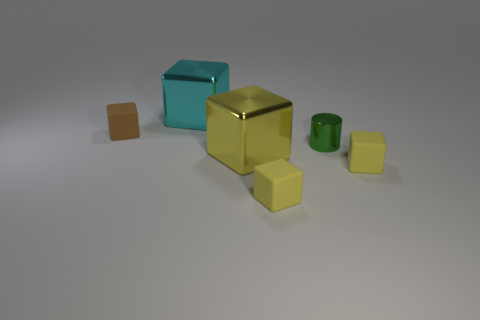Subtract all cyan cylinders. How many yellow blocks are left? 3 Subtract all cyan blocks. How many blocks are left? 4 Subtract all cyan cubes. How many cubes are left? 4 Subtract 1 cubes. How many cubes are left? 4 Add 2 yellow rubber blocks. How many objects exist? 8 Subtract all cyan blocks. Subtract all brown cylinders. How many blocks are left? 4 Subtract all cubes. How many objects are left? 1 Add 5 shiny cylinders. How many shiny cylinders are left? 6 Add 4 tiny gray matte balls. How many tiny gray matte balls exist? 4 Subtract 1 cyan cubes. How many objects are left? 5 